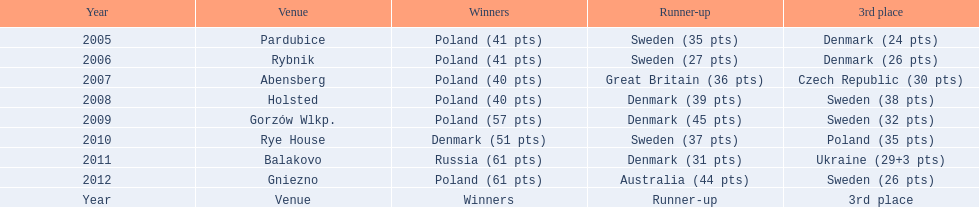During which years did denmark secure a position in the top 3 at the team speedway junior world championship? 2005, 2006, 2008, 2009, 2010, 2011. In which year was denmark just 2 points away from a higher ranking? 2006. Parse the table in full. {'header': ['Year', 'Venue', 'Winners', 'Runner-up', '3rd place'], 'rows': [['2005', 'Pardubice', 'Poland (41 pts)', 'Sweden (35 pts)', 'Denmark (24 pts)'], ['2006', 'Rybnik', 'Poland (41 pts)', 'Sweden (27 pts)', 'Denmark (26 pts)'], ['2007', 'Abensberg', 'Poland (40 pts)', 'Great Britain (36 pts)', 'Czech Republic (30 pts)'], ['2008', 'Holsted', 'Poland (40 pts)', 'Denmark (39 pts)', 'Sweden (38 pts)'], ['2009', 'Gorzów Wlkp.', 'Poland (57 pts)', 'Denmark (45 pts)', 'Sweden (32 pts)'], ['2010', 'Rye House', 'Denmark (51 pts)', 'Sweden (37 pts)', 'Poland (35 pts)'], ['2011', 'Balakovo', 'Russia (61 pts)', 'Denmark (31 pts)', 'Ukraine (29+3 pts)'], ['2012', 'Gniezno', 'Poland (61 pts)', 'Australia (44 pts)', 'Sweden (26 pts)'], ['Year', 'Venue', 'Winners', 'Runner-up', '3rd place']]} What was denmark's rank in the year they were only 2 points short of a higher position? 3rd place. 